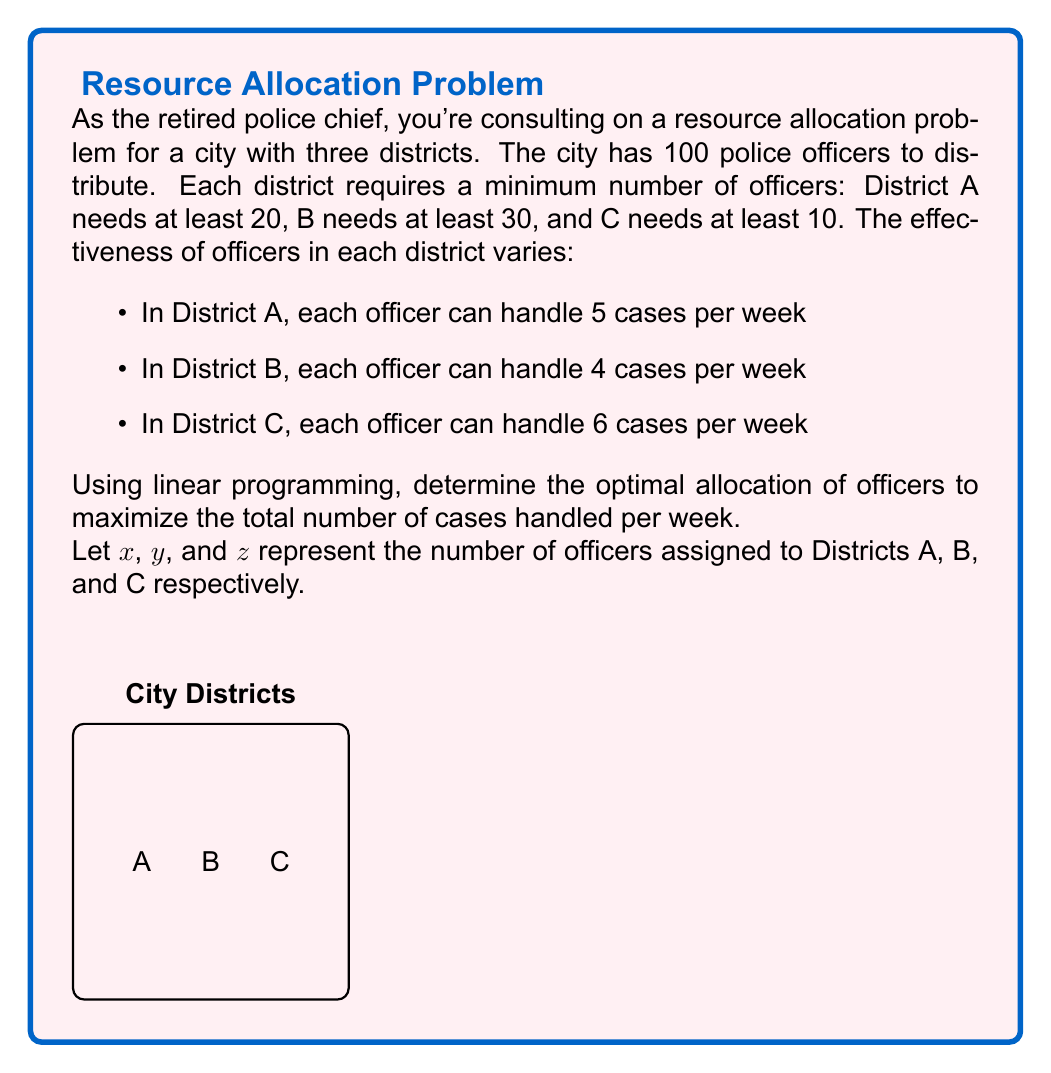Show me your answer to this math problem. Let's approach this step-by-step using linear programming:

1) Define the objective function:
   We want to maximize the total cases handled per week.
   $$\text{Maximize: } 5x + 4y + 6z$$

2) Set up the constraints:
   a) Minimum officers per district:
      $$x \geq 20$$
      $$y \geq 30$$
      $$z \geq 10$$
   b) Total number of officers:
      $$x + y + z = 100$$
   c) Non-negativity:
      $$x, y, z \geq 0$$

3) Solve using the simplex method or linear programming software.

4) The optimal solution is:
   $$x = 20, y = 30, z = 50$$

5) Verify the solution:
   - It satisfies all constraints
   - Total officers: $20 + 30 + 50 = 100$
   - Maximum cases handled: $5(20) + 4(30) + 6(50) = 100 + 120 + 300 = 520$

6) Any other allocation would result in fewer cases handled per week.
Answer: District A: 20 officers, District B: 30 officers, District C: 50 officers. Maximum cases handled: 520 per week. 